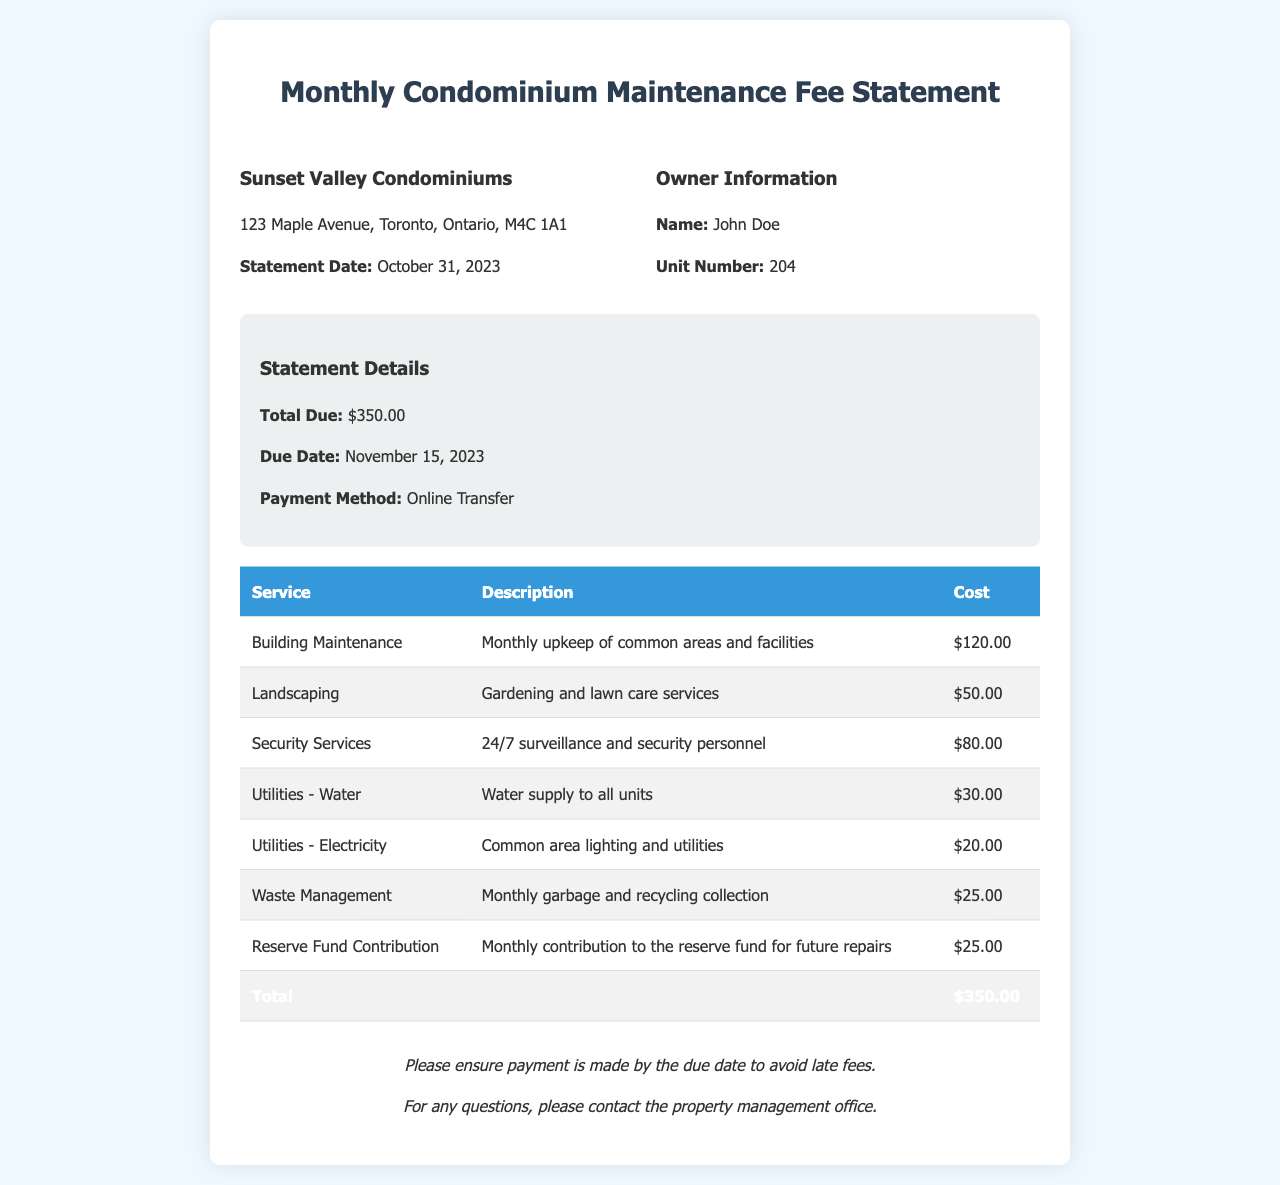What is the total due amount? The total due amount is stated in the statement details section of the document.
Answer: $350.00 What is the due date for payment? The due date is mentioned in the statement details section, indicating when payment must be made.
Answer: November 15, 2023 Who is the owner of the unit? The owner's name is listed in the owner information section of the document.
Answer: John Doe What service costs $80.00? This amount is listed under one of the services provided and is specifically for security services.
Answer: Security Services What is the cost for landscaping? The cost for landscaping is mentioned in the breakdown of services provided in the document.
Answer: $50.00 How much is allocated for the reserve fund contribution? This amount is detailed in the table of services, indicating a specific contribution to future repairs.
Answer: $25.00 What type of payment method is suggested? The document specifies the payment method in the statement details section.
Answer: Online Transfer What was the main service provided for common areas? This service is mentioned in the breakdown and is related to the maintenance of shared spaces.
Answer: Building Maintenance How many services are listed in the document? The total number of distinct services provided can be counted from the breakdown in the table.
Answer: 7 